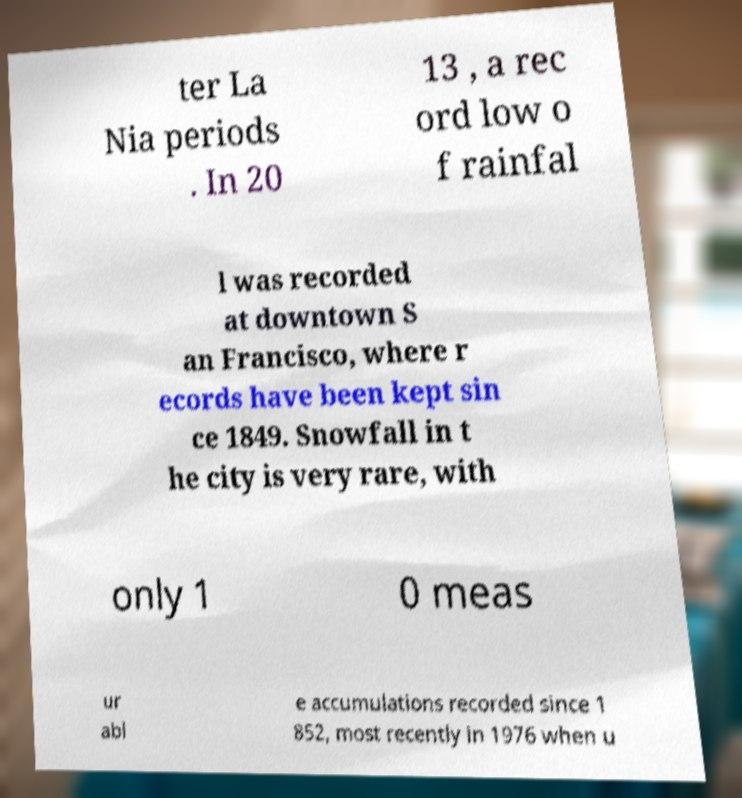Could you extract and type out the text from this image? ter La Nia periods . In 20 13 , a rec ord low o f rainfal l was recorded at downtown S an Francisco, where r ecords have been kept sin ce 1849. Snowfall in t he city is very rare, with only 1 0 meas ur abl e accumulations recorded since 1 852, most recently in 1976 when u 